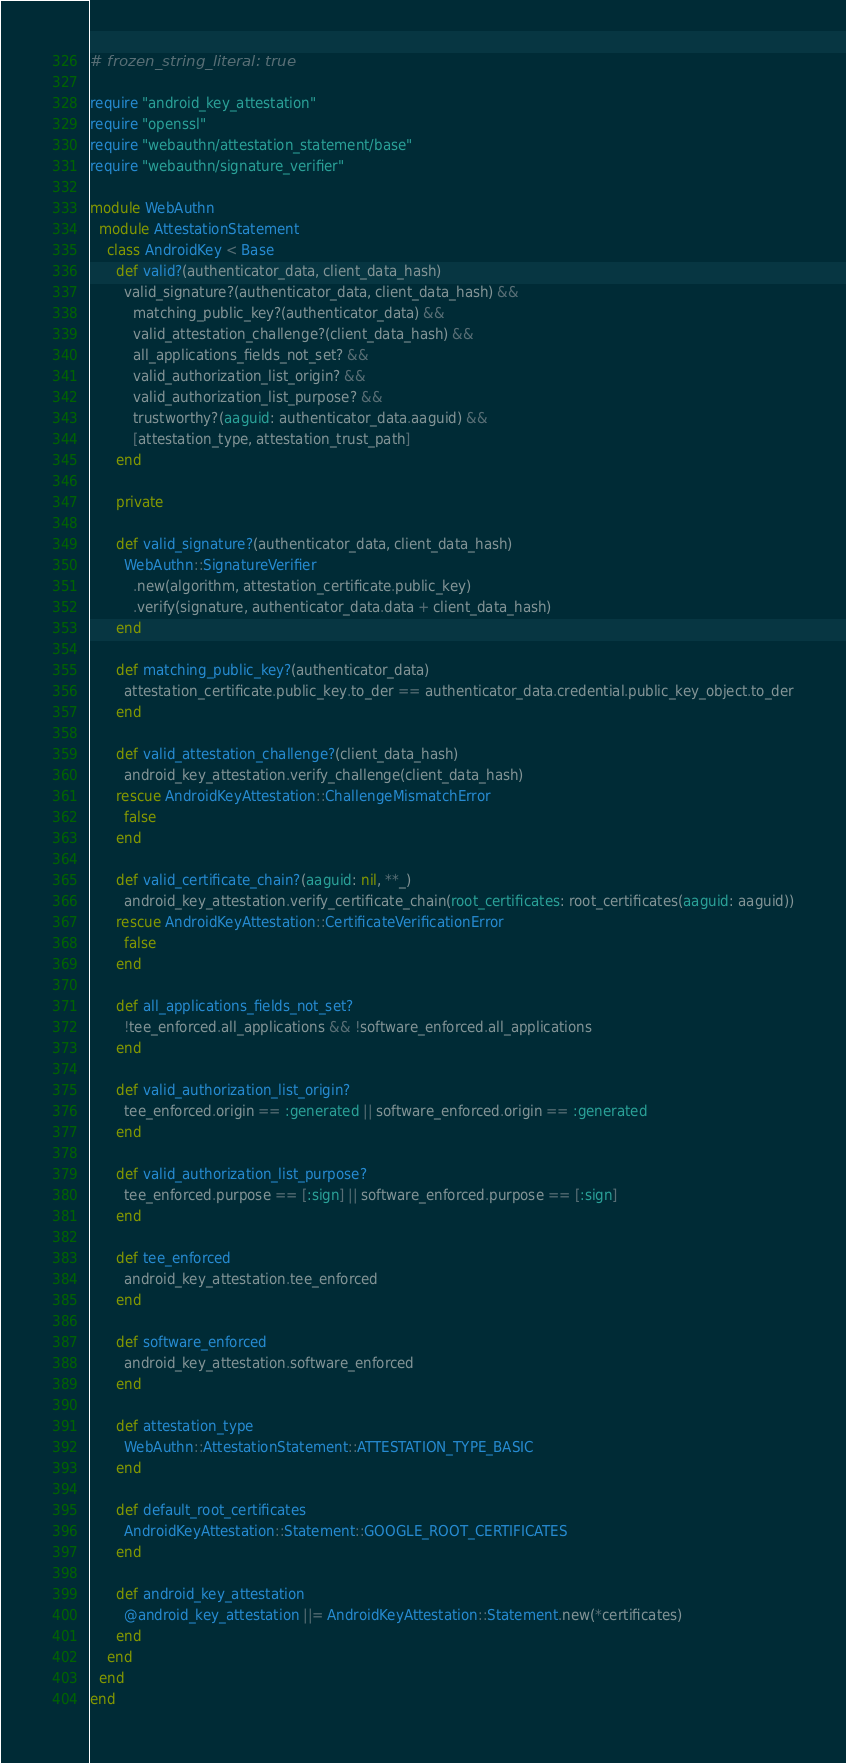<code> <loc_0><loc_0><loc_500><loc_500><_Ruby_># frozen_string_literal: true

require "android_key_attestation"
require "openssl"
require "webauthn/attestation_statement/base"
require "webauthn/signature_verifier"

module WebAuthn
  module AttestationStatement
    class AndroidKey < Base
      def valid?(authenticator_data, client_data_hash)
        valid_signature?(authenticator_data, client_data_hash) &&
          matching_public_key?(authenticator_data) &&
          valid_attestation_challenge?(client_data_hash) &&
          all_applications_fields_not_set? &&
          valid_authorization_list_origin? &&
          valid_authorization_list_purpose? &&
          trustworthy?(aaguid: authenticator_data.aaguid) &&
          [attestation_type, attestation_trust_path]
      end

      private

      def valid_signature?(authenticator_data, client_data_hash)
        WebAuthn::SignatureVerifier
          .new(algorithm, attestation_certificate.public_key)
          .verify(signature, authenticator_data.data + client_data_hash)
      end

      def matching_public_key?(authenticator_data)
        attestation_certificate.public_key.to_der == authenticator_data.credential.public_key_object.to_der
      end

      def valid_attestation_challenge?(client_data_hash)
        android_key_attestation.verify_challenge(client_data_hash)
      rescue AndroidKeyAttestation::ChallengeMismatchError
        false
      end

      def valid_certificate_chain?(aaguid: nil, **_)
        android_key_attestation.verify_certificate_chain(root_certificates: root_certificates(aaguid: aaguid))
      rescue AndroidKeyAttestation::CertificateVerificationError
        false
      end

      def all_applications_fields_not_set?
        !tee_enforced.all_applications && !software_enforced.all_applications
      end

      def valid_authorization_list_origin?
        tee_enforced.origin == :generated || software_enforced.origin == :generated
      end

      def valid_authorization_list_purpose?
        tee_enforced.purpose == [:sign] || software_enforced.purpose == [:sign]
      end

      def tee_enforced
        android_key_attestation.tee_enforced
      end

      def software_enforced
        android_key_attestation.software_enforced
      end

      def attestation_type
        WebAuthn::AttestationStatement::ATTESTATION_TYPE_BASIC
      end

      def default_root_certificates
        AndroidKeyAttestation::Statement::GOOGLE_ROOT_CERTIFICATES
      end

      def android_key_attestation
        @android_key_attestation ||= AndroidKeyAttestation::Statement.new(*certificates)
      end
    end
  end
end
</code> 